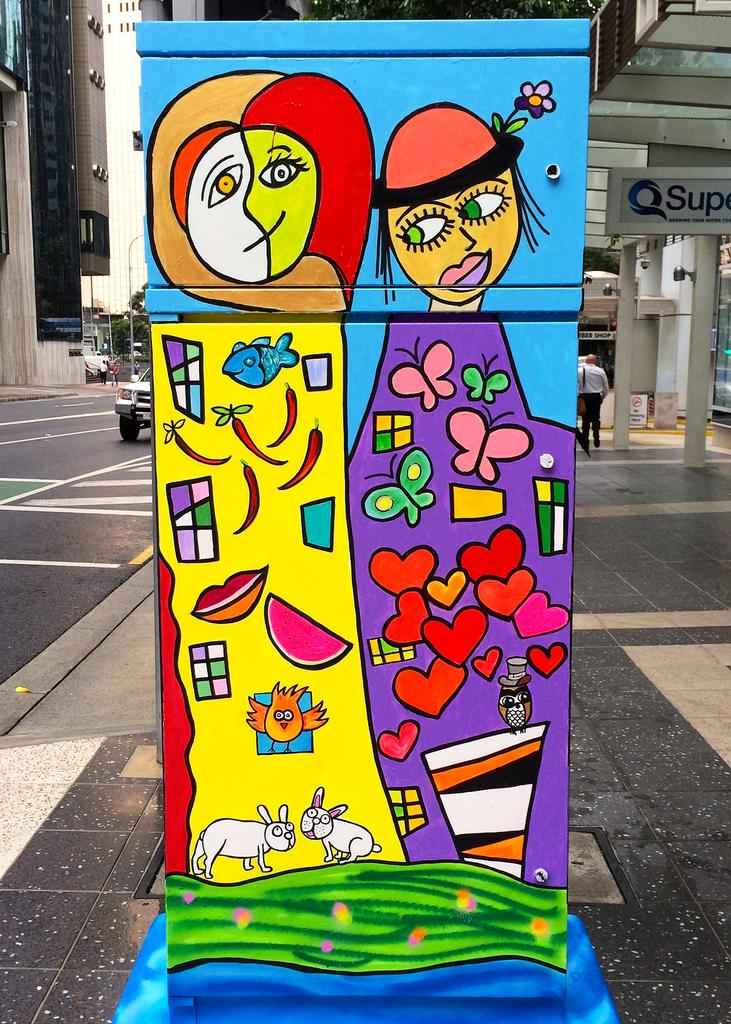What type of structures can be seen in the image? There are buildings in the image. Where is the car located in the image? The car is on the left side of the image. What is present on the right side of the image? There is a person on the right side of the image. What can be found in the middle of the image? There is an art piece in the middle of the image. How many bikes are parked next to the person on the right side of the image? There are no bikes present in the image; only a person is visible on the right side. Can you see any goats or fairies in the image? No, there are no goats or fairies present in the image. 